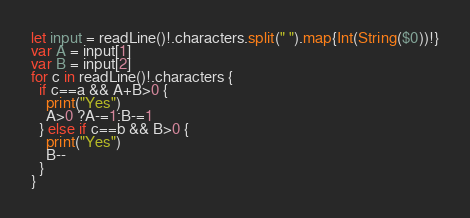Convert code to text. <code><loc_0><loc_0><loc_500><loc_500><_Swift_>let input = readLine()!.characters.split(" ").map{Int(String($0))!}
var A = input[1]
var B = input[2]
for c in readLine()!.characters {
  if c==a && A+B>0 {
    print("Yes")
    A>0 ?A-=1:B-=1
  } else if c==b && B>0 {
    print("Yes")
    B--
  }
}</code> 